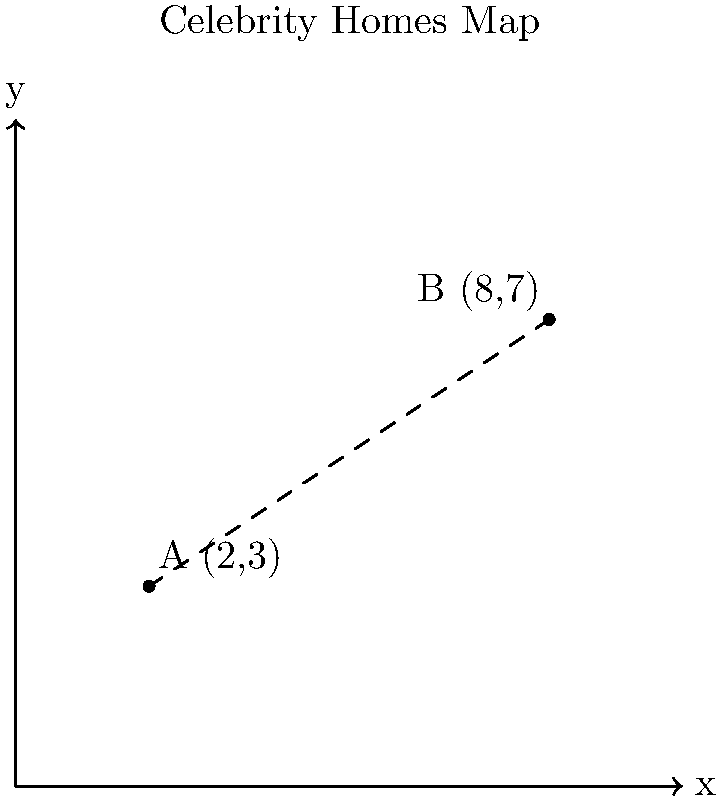In the latest issue of your favorite celebrity gossip magazine, you stumble upon an intriguing map showing the locations of two A-list celebrities' homes. The map uses a coordinate system where each unit represents 1 mile. Celebrity A's mansion is located at (2,3), while Celebrity B's lavish estate is at (8,7). How many miles apart are these two star-studded residences? To find the distance between the two celebrity homes, we can use the distance formula derived from the Pythagorean theorem:

$$d = \sqrt{(x_2 - x_1)^2 + (y_2 - y_1)^2}$$

Where $(x_1, y_1)$ represents the coordinates of Celebrity A's home and $(x_2, y_2)$ represents the coordinates of Celebrity B's home.

Step 1: Identify the coordinates
Celebrity A: $(x_1, y_1) = (2, 3)$
Celebrity B: $(x_2, y_2) = (8, 7)$

Step 2: Plug the values into the distance formula
$$d = \sqrt{(8 - 2)^2 + (7 - 3)^2}$$

Step 3: Simplify the expressions inside the parentheses
$$d = \sqrt{6^2 + 4^2}$$

Step 4: Calculate the squares
$$d = \sqrt{36 + 16}$$

Step 5: Add the values under the square root
$$d = \sqrt{52}$$

Step 6: Simplify the square root (if possible)
$\sqrt{52}$ can be simplified to $2\sqrt{13}$

Therefore, the distance between the two celebrity homes is $2\sqrt{13}$ miles.
Answer: $2\sqrt{13}$ miles 